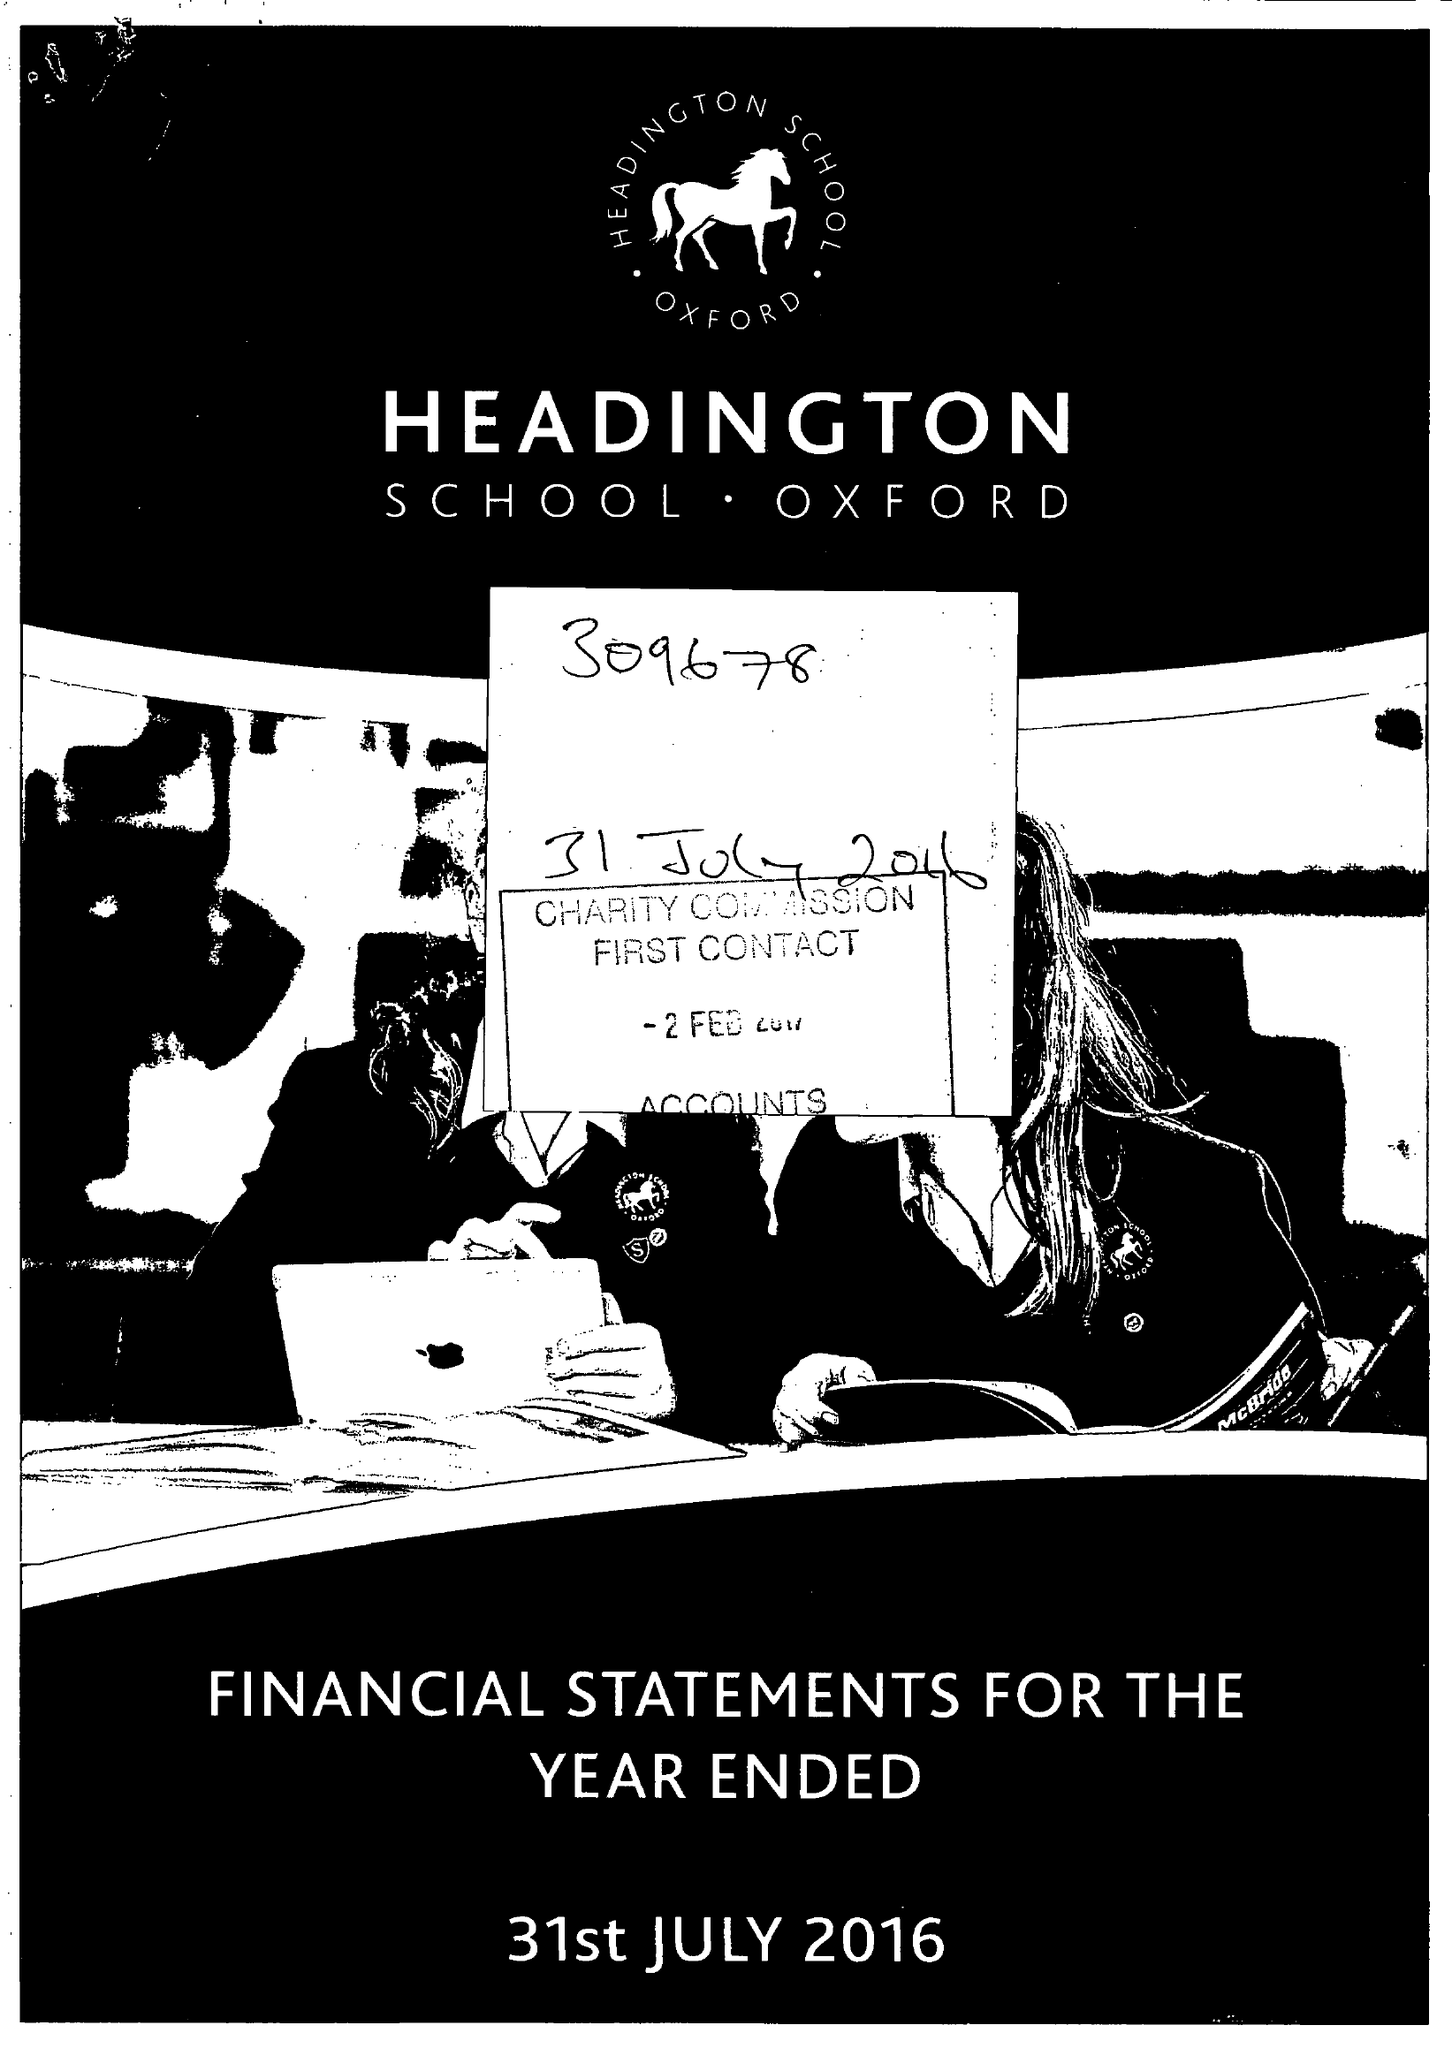What is the value for the address__street_line?
Answer the question using a single word or phrase. HEADINGTON ROAD 